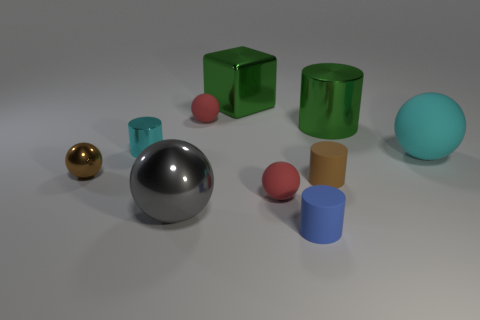What number of other things are there of the same shape as the large gray thing?
Your response must be concise. 4. How many matte spheres have the same color as the large metal cylinder?
Your response must be concise. 0. What is the size of the green cylinder that is made of the same material as the gray thing?
Ensure brevity in your answer.  Large. What number of things are either big green rubber things or things?
Provide a short and direct response. 10. What is the color of the small cylinder that is right of the blue matte object?
Make the answer very short. Brown. The other metal thing that is the same shape as the brown metallic object is what size?
Offer a terse response. Large. How many things are either brown objects that are to the left of the small cyan thing or tiny balls to the left of the green cylinder?
Offer a very short reply. 3. There is a rubber sphere that is in front of the large green shiny cylinder and to the left of the big green cylinder; what size is it?
Your answer should be very brief. Small. There is a large matte thing; does it have the same shape as the big green thing that is to the right of the green metal block?
Offer a terse response. No. What number of things are either things behind the large cylinder or green things?
Your answer should be compact. 3. 